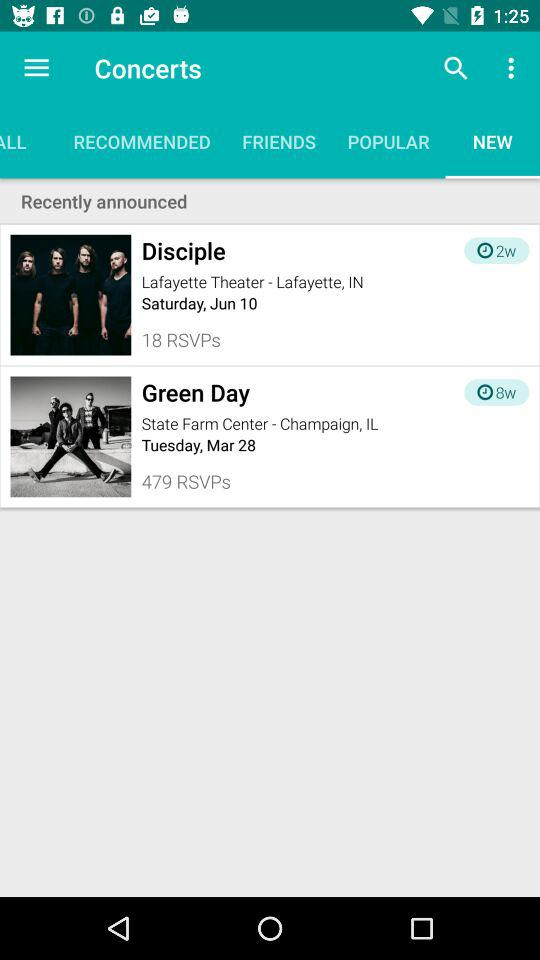Which tab has been selected? The selected tab is "NEW". 